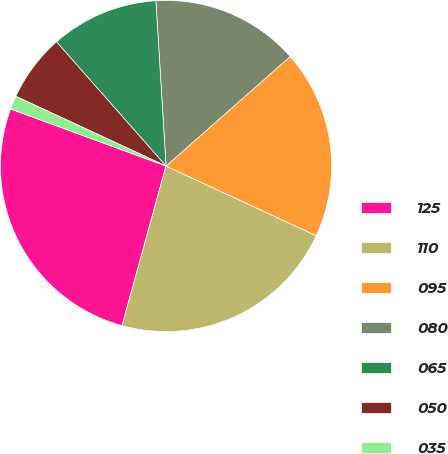Convert chart. <chart><loc_0><loc_0><loc_500><loc_500><pie_chart><fcel>125<fcel>110<fcel>095<fcel>080<fcel>065<fcel>050<fcel>035<nl><fcel>26.32%<fcel>22.37%<fcel>18.42%<fcel>14.47%<fcel>10.53%<fcel>6.58%<fcel>1.32%<nl></chart> 